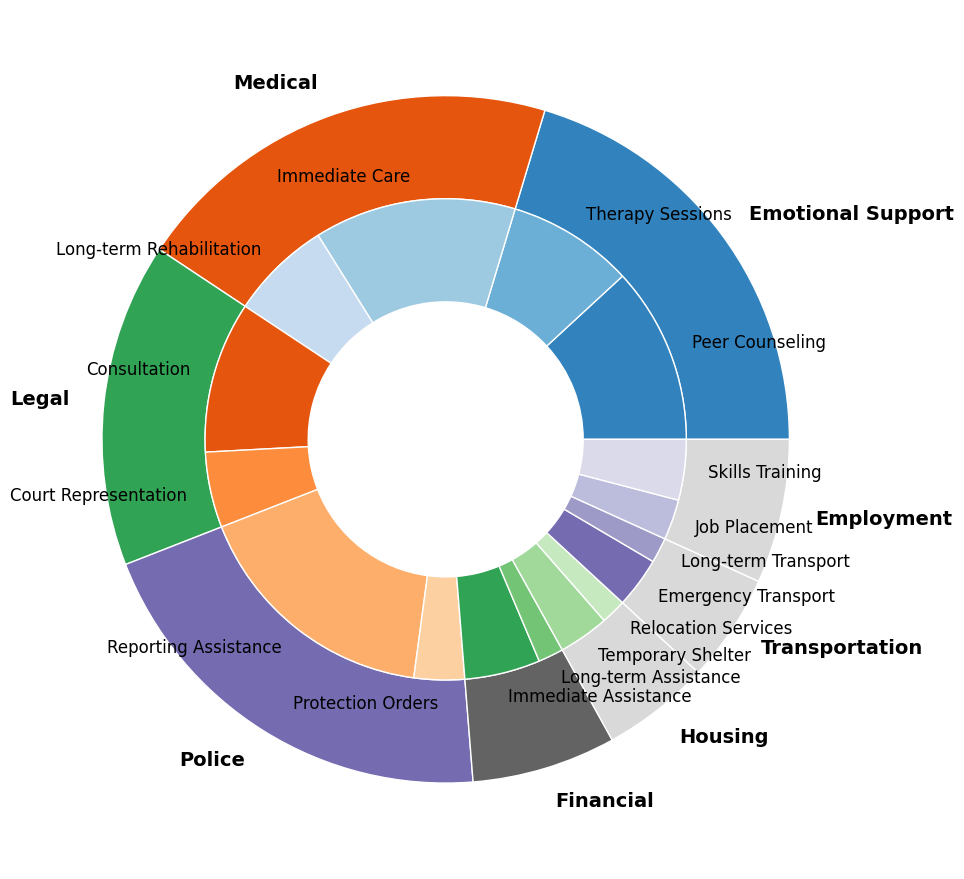How many more people utilized Medical/Immediate Care services compared to Transportation/Long-term Transport services? From the figure, Medical/Immediate Care shows 40, and Transportation/Long-term Transport shows 5. The difference is 40 - 5.
Answer: 35 Which subcategory within the Legal category was utilized more frequently, Consultation or Court Representation? From the chart, Legal/Consultation has a frequency of 30, whereas Legal/Court Representation has a frequency of 15. Thus, Consultation is used more frequently.
Answer: Consultation What is the total frequency of services utilized for Housing? Both subcategories for Housing, Temporary Shelter and Relocation Services, are 10 and 5, respectively. Summing them up gives 10 + 5.
Answer: 15 Is the frequency of Emotional Support/Therapy Sessions greater than that of Legal/Court Representation? Emotional Support/Therapy Sessions has a frequency of 25, while Legal/Court Representation has 15. Since 25 is greater than 15, the answer is yes.
Answer: Yes What are the frequencies of the most and least utilized subcategories? The most utilized subcategory is Police/Reporting Assistance at 50, and the least utilized subcategory is Financial/Long-term Assistance at 5.
Answer: Most: 50, Least: 5 What is the combined frequency of all Police-related services? Police/Reporting Assistance is 50 and Police/Protection Orders is 10. Combined, it gives 50 + 10.
Answer: 60 Among the Financial-related services, which one was the least utilized? The chart indicates Financial/Immediate Assistance with a frequency of 15, and Financial/Long-term Assistance with a frequency of 5. The least utilized is Financial/Long-term Assistance.
Answer: Long-term Assistance How many more people utilized Employment/Skills Training than Employment/Job Placement? Employment/Skills Training has 12, while Employment/Job Placement has 8. The difference is calculated as 12 - 8.
Answer: 4 Rank the categories from most to least utilized based on their total frequency. By summing up subcategories: 
1. Police: 50 + 10 = 60
2. Medical: 40 + 20 = 60
3. Emotional Support: 35 + 25 = 60
4. Legal: 30 + 15 = 45
5. Financial: 15 + 5 = 20
6. Transportation: 10 + 5 = 15
7. Housing: 10 + 5 = 15
8. Employment: 8 + 12 = 20
Ordered from most to least: Police, Medical, Emotional Support, Legal, Financial, Employment, Transportation, Housing.
Answer: Police, Medical, Emotional Support, Legal, Financial, Employment, Transportation, Housing 